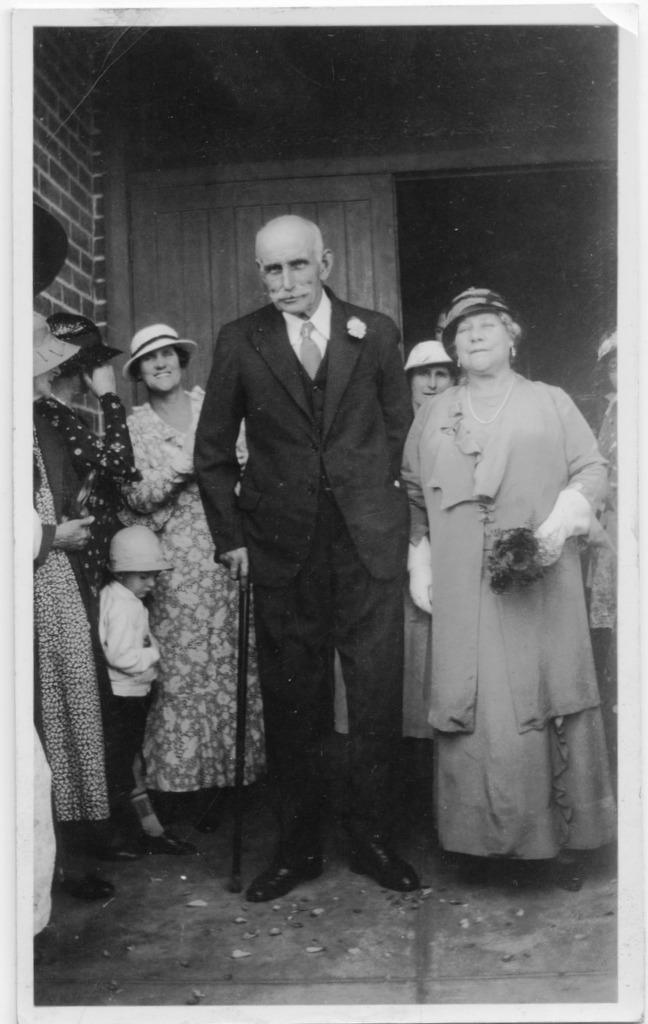Please provide a concise description of this image. This looks like an old black and white image. I can see a group of people standing. In the background, I think this is a wooden door. 